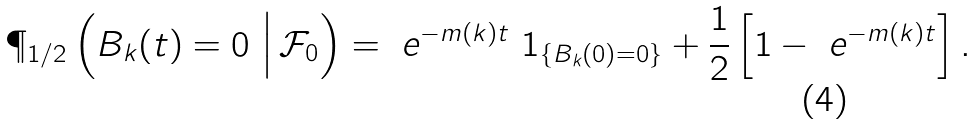Convert formula to latex. <formula><loc_0><loc_0><loc_500><loc_500>\P _ { 1 / 2 } \left ( B _ { k } ( t ) = 0 \ \Big | \, \mathcal { F } _ { 0 } \right ) = \ e ^ { - m ( k ) t } \ 1 _ { \{ B _ { k } ( 0 ) = 0 \} } + \frac { 1 } { 2 } \left [ 1 - \ e ^ { - m ( k ) t } \right ] .</formula> 